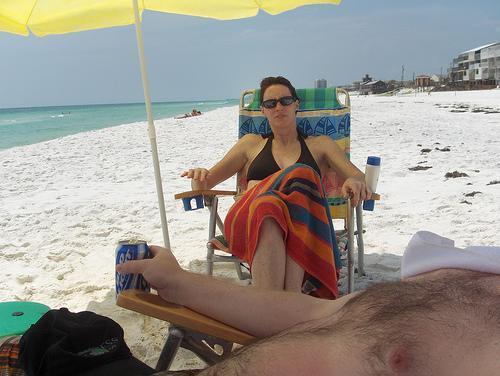How many people are pictured?
Give a very brief answer. 2. 